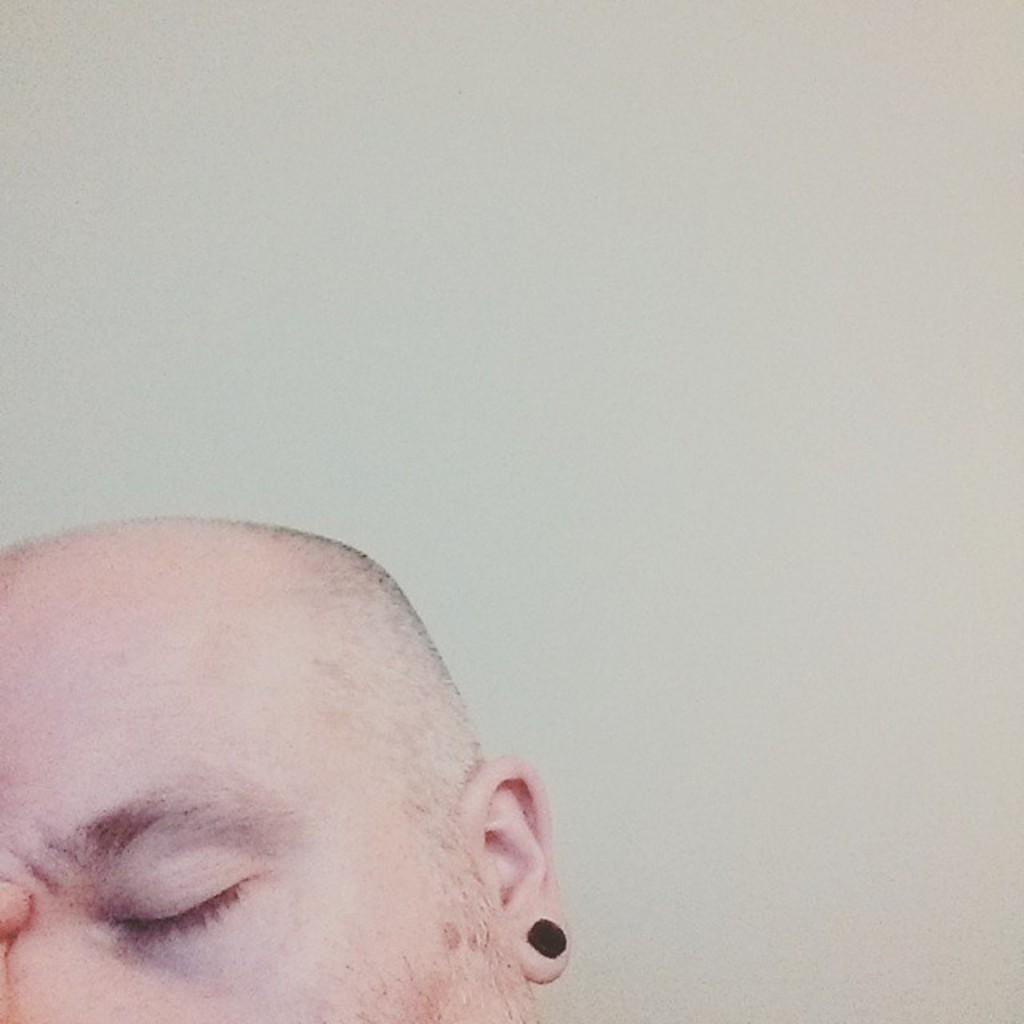What is the main subject of the image? There is a person's head in the image. What is a notable feature of the person's head? The person's head is bald on the top. What can be seen in the background of the image? There is a wall in the background of the image. How many sisters are playing basketball in the image? There are no sisters or basketball present in the image; it only features a person's head with a bald top and a wall in the background. 